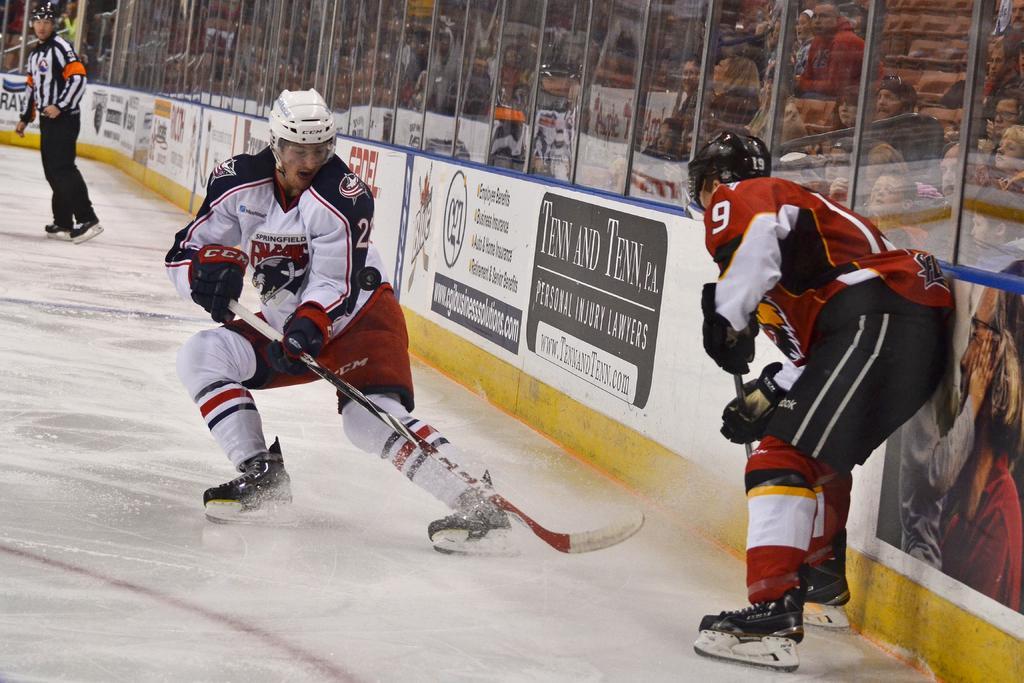Please provide a concise description of this image. In this picture we can see a person wearing a helmet and holding an ice hockey stick. We can see the text, images of people and a few things on the posters. There is a person holding an object. We can see a man wearing a helmet and ice skates visible on the floor. We can see glass objects. Through these glass objects, we can see some people sitting on the chairs and other objects. 